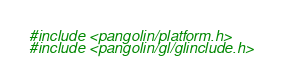<code> <loc_0><loc_0><loc_500><loc_500><_ObjectiveC_>#include <pangolin/platform.h>
#include <pangolin/gl/glinclude.h></code> 